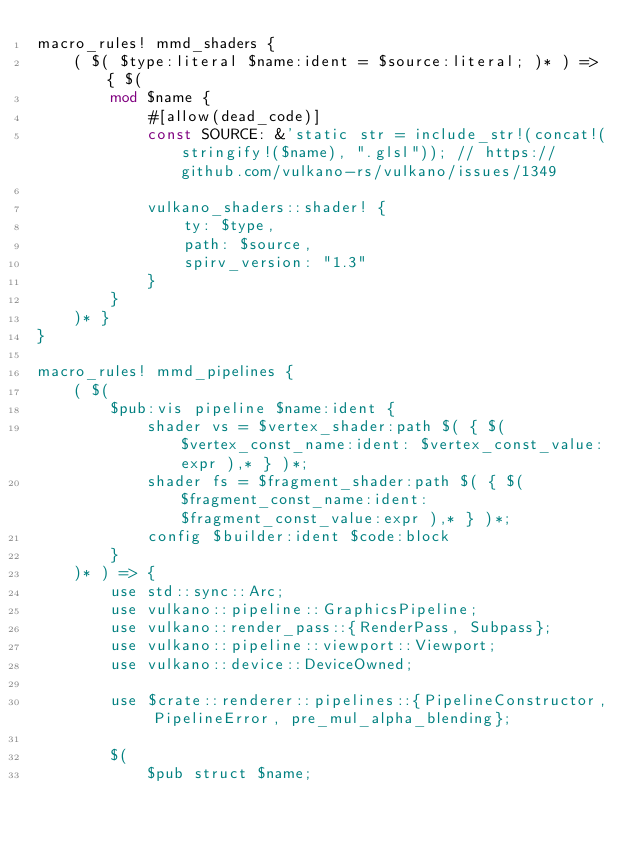<code> <loc_0><loc_0><loc_500><loc_500><_Rust_>macro_rules! mmd_shaders {
	( $( $type:literal $name:ident = $source:literal; )* ) => { $(
		mod $name {
			#[allow(dead_code)]
			const SOURCE: &'static str = include_str!(concat!(stringify!($name), ".glsl")); // https://github.com/vulkano-rs/vulkano/issues/1349
			
			vulkano_shaders::shader! {
				ty: $type,
				path: $source,
				spirv_version: "1.3"
			}
		}
	)* }
}

macro_rules! mmd_pipelines {
	( $(
		$pub:vis pipeline $name:ident {
			shader vs = $vertex_shader:path $( { $( $vertex_const_name:ident: $vertex_const_value:expr ),* } )*;
			shader fs = $fragment_shader:path $( { $( $fragment_const_name:ident: $fragment_const_value:expr ),* } )*;
			config $builder:ident $code:block
		}
	)* ) => {
		use std::sync::Arc;
		use vulkano::pipeline::GraphicsPipeline;
		use vulkano::render_pass::{RenderPass, Subpass};
		use vulkano::pipeline::viewport::Viewport;
		use vulkano::device::DeviceOwned;
		
		use $crate::renderer::pipelines::{PipelineConstructor, PipelineError, pre_mul_alpha_blending};
		
		$(
			$pub struct $name;
			</code> 